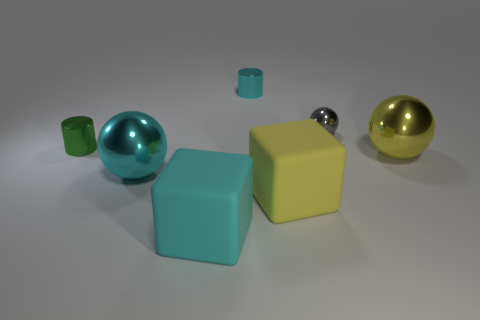Subtract all yellow balls. How many balls are left? 2 Add 2 large brown objects. How many objects exist? 9 Subtract all cyan cylinders. How many cylinders are left? 1 Subtract all blocks. How many objects are left? 5 Subtract 2 cubes. How many cubes are left? 0 Add 4 large cyan shiny things. How many large cyan shiny things exist? 5 Subtract 0 purple spheres. How many objects are left? 7 Subtract all purple spheres. Subtract all green cylinders. How many spheres are left? 3 Subtract all yellow blocks. How many cyan spheres are left? 1 Subtract all large purple cylinders. Subtract all gray shiny objects. How many objects are left? 6 